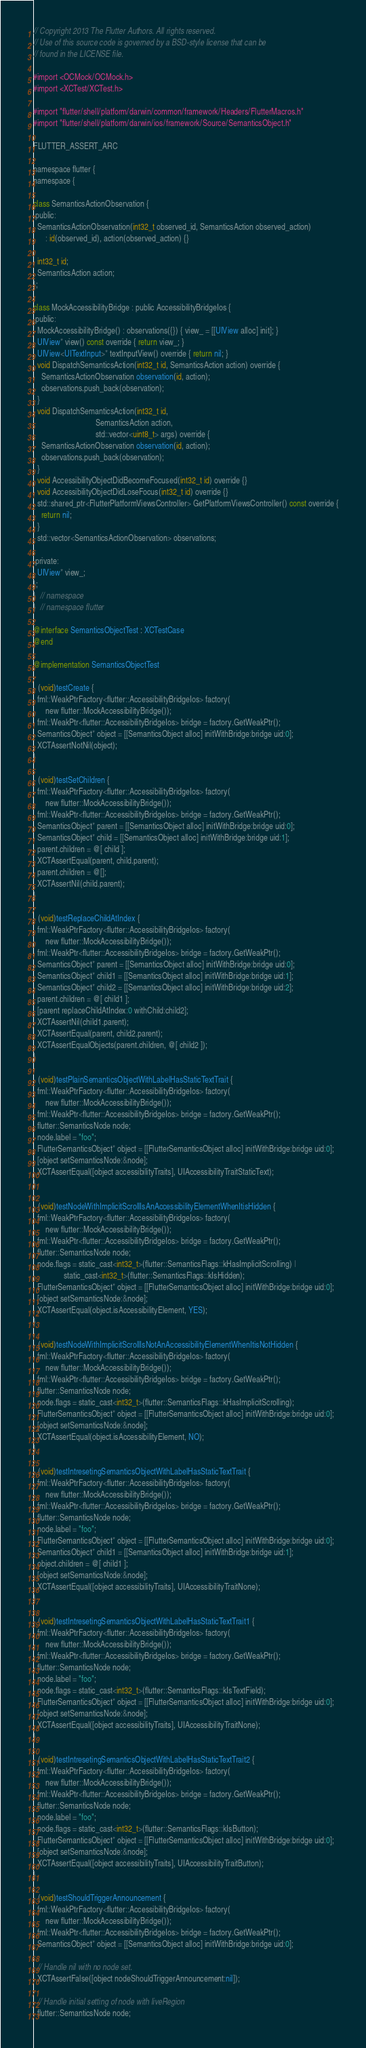<code> <loc_0><loc_0><loc_500><loc_500><_ObjectiveC_>// Copyright 2013 The Flutter Authors. All rights reserved.
// Use of this source code is governed by a BSD-style license that can be
// found in the LICENSE file.

#import <OCMock/OCMock.h>
#import <XCTest/XCTest.h>

#import "flutter/shell/platform/darwin/common/framework/Headers/FlutterMacros.h"
#import "flutter/shell/platform/darwin/ios/framework/Source/SemanticsObject.h"

FLUTTER_ASSERT_ARC

namespace flutter {
namespace {

class SemanticsActionObservation {
 public:
  SemanticsActionObservation(int32_t observed_id, SemanticsAction observed_action)
      : id(observed_id), action(observed_action) {}

  int32_t id;
  SemanticsAction action;
};

class MockAccessibilityBridge : public AccessibilityBridgeIos {
 public:
  MockAccessibilityBridge() : observations({}) { view_ = [[UIView alloc] init]; }
  UIView* view() const override { return view_; }
  UIView<UITextInput>* textInputView() override { return nil; }
  void DispatchSemanticsAction(int32_t id, SemanticsAction action) override {
    SemanticsActionObservation observation(id, action);
    observations.push_back(observation);
  }
  void DispatchSemanticsAction(int32_t id,
                               SemanticsAction action,
                               std::vector<uint8_t> args) override {
    SemanticsActionObservation observation(id, action);
    observations.push_back(observation);
  }
  void AccessibilityObjectDidBecomeFocused(int32_t id) override {}
  void AccessibilityObjectDidLoseFocus(int32_t id) override {}
  std::shared_ptr<FlutterPlatformViewsController> GetPlatformViewsController() const override {
    return nil;
  }
  std::vector<SemanticsActionObservation> observations;

 private:
  UIView* view_;
};
}  // namespace
}  // namespace flutter

@interface SemanticsObjectTest : XCTestCase
@end

@implementation SemanticsObjectTest

- (void)testCreate {
  fml::WeakPtrFactory<flutter::AccessibilityBridgeIos> factory(
      new flutter::MockAccessibilityBridge());
  fml::WeakPtr<flutter::AccessibilityBridgeIos> bridge = factory.GetWeakPtr();
  SemanticsObject* object = [[SemanticsObject alloc] initWithBridge:bridge uid:0];
  XCTAssertNotNil(object);
}

- (void)testSetChildren {
  fml::WeakPtrFactory<flutter::AccessibilityBridgeIos> factory(
      new flutter::MockAccessibilityBridge());
  fml::WeakPtr<flutter::AccessibilityBridgeIos> bridge = factory.GetWeakPtr();
  SemanticsObject* parent = [[SemanticsObject alloc] initWithBridge:bridge uid:0];
  SemanticsObject* child = [[SemanticsObject alloc] initWithBridge:bridge uid:1];
  parent.children = @[ child ];
  XCTAssertEqual(parent, child.parent);
  parent.children = @[];
  XCTAssertNil(child.parent);
}

- (void)testReplaceChildAtIndex {
  fml::WeakPtrFactory<flutter::AccessibilityBridgeIos> factory(
      new flutter::MockAccessibilityBridge());
  fml::WeakPtr<flutter::AccessibilityBridgeIos> bridge = factory.GetWeakPtr();
  SemanticsObject* parent = [[SemanticsObject alloc] initWithBridge:bridge uid:0];
  SemanticsObject* child1 = [[SemanticsObject alloc] initWithBridge:bridge uid:1];
  SemanticsObject* child2 = [[SemanticsObject alloc] initWithBridge:bridge uid:2];
  parent.children = @[ child1 ];
  [parent replaceChildAtIndex:0 withChild:child2];
  XCTAssertNil(child1.parent);
  XCTAssertEqual(parent, child2.parent);
  XCTAssertEqualObjects(parent.children, @[ child2 ]);
}

- (void)testPlainSemanticsObjectWithLabelHasStaticTextTrait {
  fml::WeakPtrFactory<flutter::AccessibilityBridgeIos> factory(
      new flutter::MockAccessibilityBridge());
  fml::WeakPtr<flutter::AccessibilityBridgeIos> bridge = factory.GetWeakPtr();
  flutter::SemanticsNode node;
  node.label = "foo";
  FlutterSemanticsObject* object = [[FlutterSemanticsObject alloc] initWithBridge:bridge uid:0];
  [object setSemanticsNode:&node];
  XCTAssertEqual([object accessibilityTraits], UIAccessibilityTraitStaticText);
}

- (void)testNodeWithImplicitScrollIsAnAccessibilityElementWhenItisHidden {
  fml::WeakPtrFactory<flutter::AccessibilityBridgeIos> factory(
      new flutter::MockAccessibilityBridge());
  fml::WeakPtr<flutter::AccessibilityBridgeIos> bridge = factory.GetWeakPtr();
  flutter::SemanticsNode node;
  node.flags = static_cast<int32_t>(flutter::SemanticsFlags::kHasImplicitScrolling) |
               static_cast<int32_t>(flutter::SemanticsFlags::kIsHidden);
  FlutterSemanticsObject* object = [[FlutterSemanticsObject alloc] initWithBridge:bridge uid:0];
  [object setSemanticsNode:&node];
  XCTAssertEqual(object.isAccessibilityElement, YES);
}

- (void)testNodeWithImplicitScrollIsNotAnAccessibilityElementWhenItisNotHidden {
  fml::WeakPtrFactory<flutter::AccessibilityBridgeIos> factory(
      new flutter::MockAccessibilityBridge());
  fml::WeakPtr<flutter::AccessibilityBridgeIos> bridge = factory.GetWeakPtr();
  flutter::SemanticsNode node;
  node.flags = static_cast<int32_t>(flutter::SemanticsFlags::kHasImplicitScrolling);
  FlutterSemanticsObject* object = [[FlutterSemanticsObject alloc] initWithBridge:bridge uid:0];
  [object setSemanticsNode:&node];
  XCTAssertEqual(object.isAccessibilityElement, NO);
}

- (void)testIntresetingSemanticsObjectWithLabelHasStaticTextTrait {
  fml::WeakPtrFactory<flutter::AccessibilityBridgeIos> factory(
      new flutter::MockAccessibilityBridge());
  fml::WeakPtr<flutter::AccessibilityBridgeIos> bridge = factory.GetWeakPtr();
  flutter::SemanticsNode node;
  node.label = "foo";
  FlutterSemanticsObject* object = [[FlutterSemanticsObject alloc] initWithBridge:bridge uid:0];
  SemanticsObject* child1 = [[SemanticsObject alloc] initWithBridge:bridge uid:1];
  object.children = @[ child1 ];
  [object setSemanticsNode:&node];
  XCTAssertEqual([object accessibilityTraits], UIAccessibilityTraitNone);
}

- (void)testIntresetingSemanticsObjectWithLabelHasStaticTextTrait1 {
  fml::WeakPtrFactory<flutter::AccessibilityBridgeIos> factory(
      new flutter::MockAccessibilityBridge());
  fml::WeakPtr<flutter::AccessibilityBridgeIos> bridge = factory.GetWeakPtr();
  flutter::SemanticsNode node;
  node.label = "foo";
  node.flags = static_cast<int32_t>(flutter::SemanticsFlags::kIsTextField);
  FlutterSemanticsObject* object = [[FlutterSemanticsObject alloc] initWithBridge:bridge uid:0];
  [object setSemanticsNode:&node];
  XCTAssertEqual([object accessibilityTraits], UIAccessibilityTraitNone);
}

- (void)testIntresetingSemanticsObjectWithLabelHasStaticTextTrait2 {
  fml::WeakPtrFactory<flutter::AccessibilityBridgeIos> factory(
      new flutter::MockAccessibilityBridge());
  fml::WeakPtr<flutter::AccessibilityBridgeIos> bridge = factory.GetWeakPtr();
  flutter::SemanticsNode node;
  node.label = "foo";
  node.flags = static_cast<int32_t>(flutter::SemanticsFlags::kIsButton);
  FlutterSemanticsObject* object = [[FlutterSemanticsObject alloc] initWithBridge:bridge uid:0];
  [object setSemanticsNode:&node];
  XCTAssertEqual([object accessibilityTraits], UIAccessibilityTraitButton);
}

- (void)testShouldTriggerAnnouncement {
  fml::WeakPtrFactory<flutter::AccessibilityBridgeIos> factory(
      new flutter::MockAccessibilityBridge());
  fml::WeakPtr<flutter::AccessibilityBridgeIos> bridge = factory.GetWeakPtr();
  SemanticsObject* object = [[SemanticsObject alloc] initWithBridge:bridge uid:0];

  // Handle nil with no node set.
  XCTAssertFalse([object nodeShouldTriggerAnnouncement:nil]);

  // Handle initial setting of node with liveRegion
  flutter::SemanticsNode node;</code> 